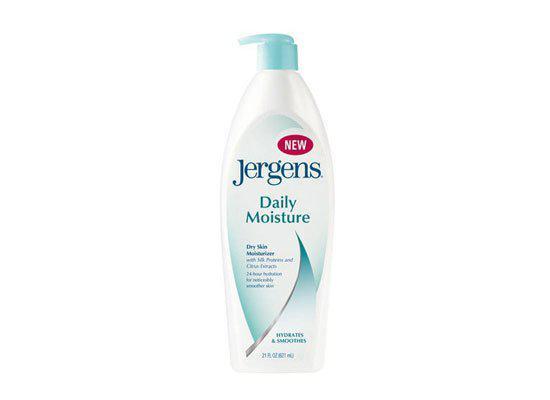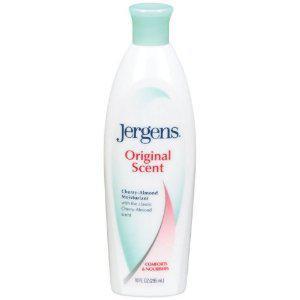The first image is the image on the left, the second image is the image on the right. Considering the images on both sides, is "There are two bottles, and only one of them has a pump." valid? Answer yes or no. Yes. The first image is the image on the left, the second image is the image on the right. For the images displayed, is the sentence "The bottle in the image on the right is turned at a slight angle." factually correct? Answer yes or no. No. 